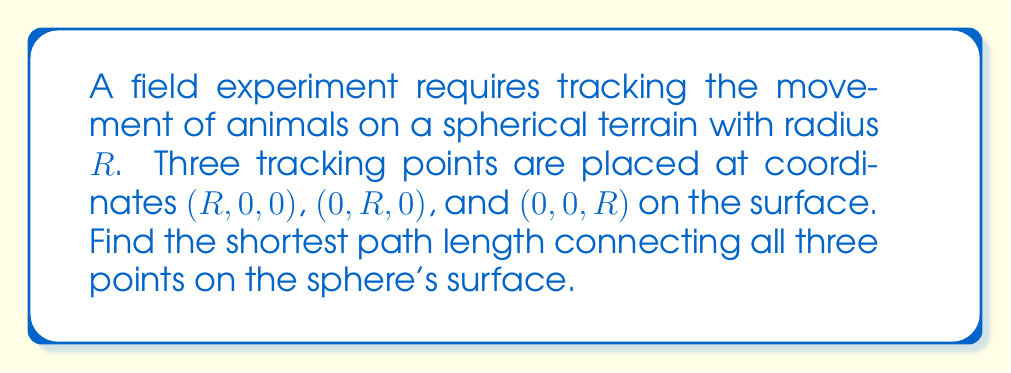Give your solution to this math problem. To solve this problem, we'll follow these steps:

1) First, recognize that the shortest path between two points on a sphere is along a great circle, which forms a spherical triangle in this case.

2) The angle between any two of these points from the center of the sphere is 90°, or $\frac{\pi}{2}$ radians. This is because they are on the axes of a Cartesian coordinate system.

3) In spherical trigonometry, for a sphere of radius $R$, the length $l$ of an arc between two points is given by:

   $$l = R \theta$$

   where $\theta$ is the central angle in radians.

4) For a right-angled spherical triangle (which we have here), we can use the spherical Pythagorean theorem:

   $$\cos(c) = \cos(a)\cos(b)$$

   where $c$ is the hypotenuse and $a$ and $b$ are the other two sides.

5) In our case, $a = b = \frac{\pi}{2}$, so:

   $$\cos(c) = \cos(\frac{\pi}{2})\cos(\frac{\pi}{2}) = 0 \cdot 0 = 0$$

6) Therefore:

   $$c = \arccos(0) = \frac{\pi}{2}$$

7) The total path length will be the sum of all three sides of the spherical triangle:

   $$L = 3R \cdot \frac{\pi}{2} = \frac{3\pi R}{2}$$

Thus, the shortest path connecting all three points on the sphere's surface has a length of $\frac{3\pi R}{2}$.
Answer: $\frac{3\pi R}{2}$ 